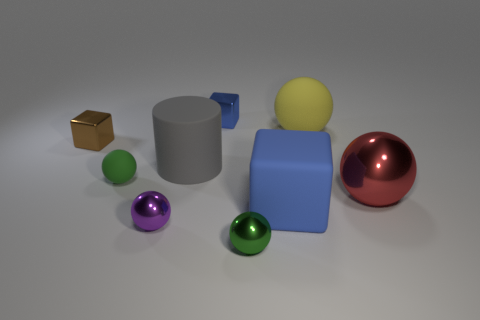The large shiny ball is what color? The large shiny ball in the image has a reflective red surface, which gives it a rich, lustrous appearance. 